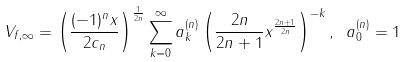<formula> <loc_0><loc_0><loc_500><loc_500>V _ { f , \infty } = \left ( \frac { ( - 1 ) ^ { n } x } { 2 c _ { n } } \right ) ^ { \frac { 1 } { 2 n } } \sum _ { k = 0 } ^ { \infty } a _ { k } ^ { ( n ) } \left ( \frac { 2 n } { 2 n + 1 } x ^ { \frac { 2 n + 1 } { 2 n } } \right ) ^ { - k } , \ a _ { 0 } ^ { ( n ) } = 1</formula> 